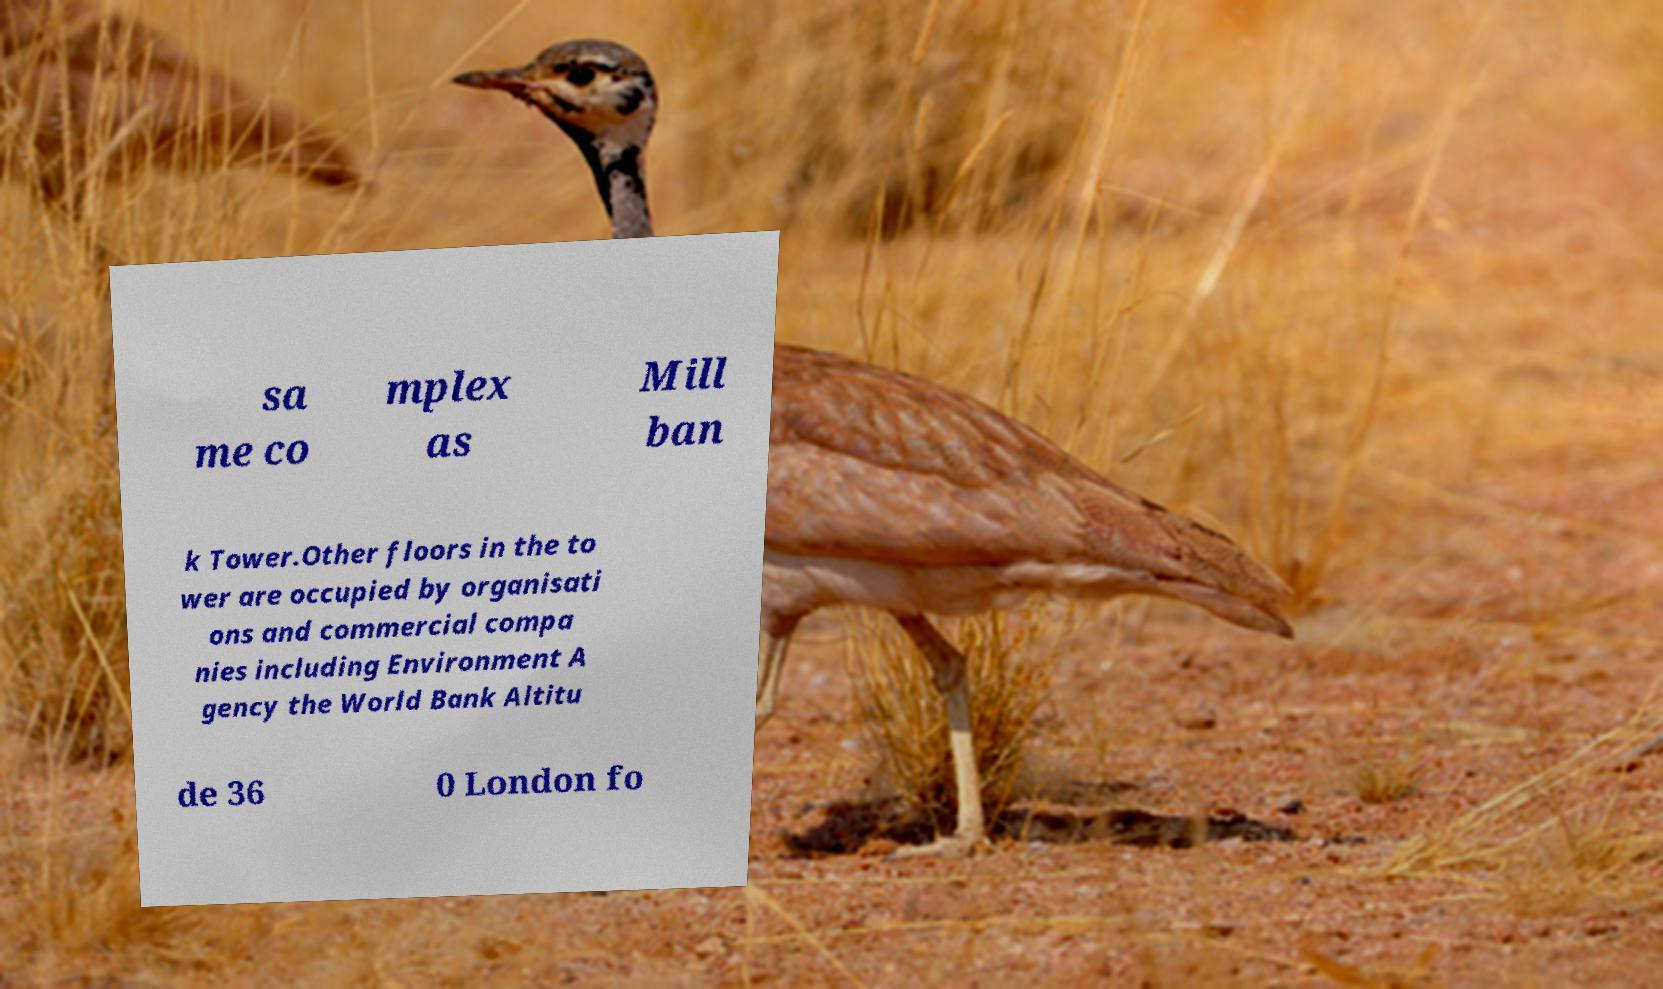Please read and relay the text visible in this image. What does it say? sa me co mplex as Mill ban k Tower.Other floors in the to wer are occupied by organisati ons and commercial compa nies including Environment A gency the World Bank Altitu de 36 0 London fo 